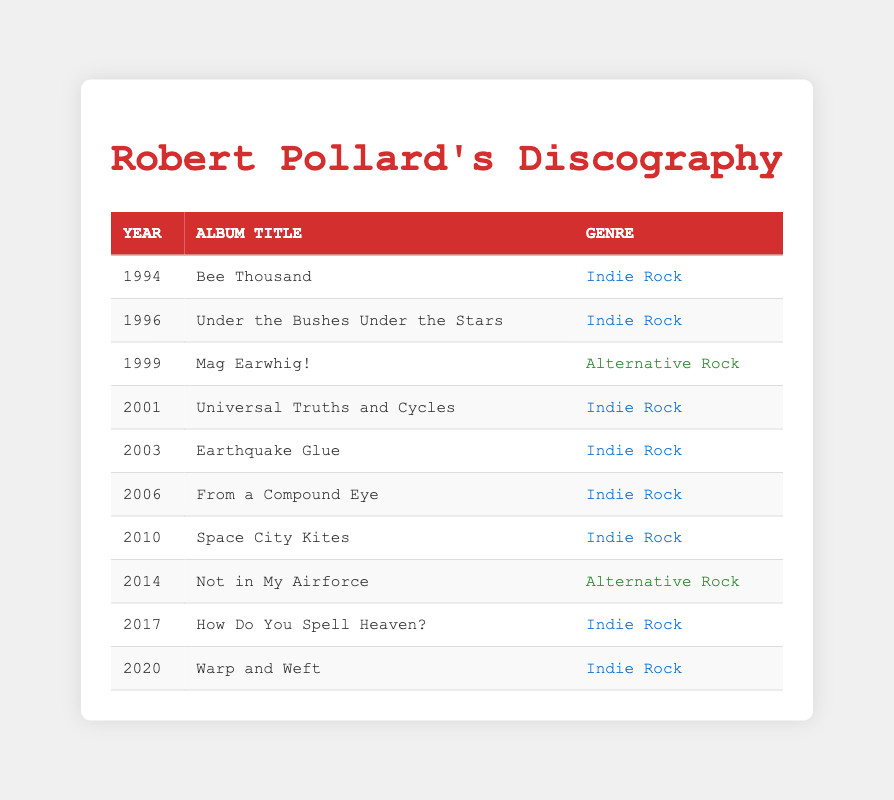What is the title of the album released in 1996? The table indicates that the album released in 1996 is "Under the Bushes Under the Stars."
Answer: Under the Bushes Under the Stars How many albums were released in the genre of Indie Rock? By counting the entries under the genre "Indie Rock" in the table, we find that there are 7 albums labeled as Indie Rock (Bee Thousand, Under the Bushes Under the Stars, Universal Truths and Cycles, Earthquake Glue, From a Compound Eye, Space City Kites, How Do You Spell Heaven?, and Warp and Weft).
Answer: 7 Was "Mag Earwhig!" released before 2000? The table shows that "Mag Earwhig!" was released in 1999, which is before the year 2000.
Answer: Yes What is the average release year of the albums listed? To get the average, we sum the years (1994 + 1996 + 1999 + 2001 + 2003 + 2006 + 2010 + 2014 + 2017 + 2020 =  2010) and divide by the total number of albums (10). So, 2010/10 = 2010.
Answer: 2010 Which genre has the least number of album releases? Looking at the genres, we have 8 Indie Rock albums and 2 Alternative Rock albums. Since 2 is less than 8, Alternative Rock has the least number of releases.
Answer: Alternative Rock 